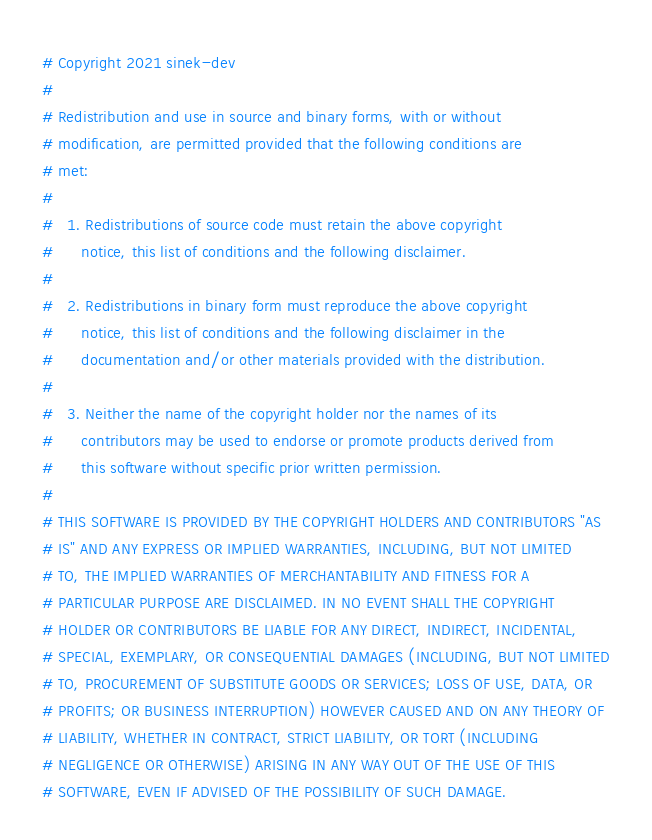Convert code to text. <code><loc_0><loc_0><loc_500><loc_500><_Python_># Copyright 2021 sinek-dev
#
# Redistribution and use in source and binary forms, with or without
# modification, are permitted provided that the following conditions are
# met:
#
#   1. Redistributions of source code must retain the above copyright
#      notice, this list of conditions and the following disclaimer.
#
#   2. Redistributions in binary form must reproduce the above copyright
#      notice, this list of conditions and the following disclaimer in the
#      documentation and/or other materials provided with the distribution.
#
#   3. Neither the name of the copyright holder nor the names of its
#      contributors may be used to endorse or promote products derived from
#      this software without specific prior written permission.
#
# THIS SOFTWARE IS PROVIDED BY THE COPYRIGHT HOLDERS AND CONTRIBUTORS "AS
# IS" AND ANY EXPRESS OR IMPLIED WARRANTIES, INCLUDING, BUT NOT LIMITED
# TO, THE IMPLIED WARRANTIES OF MERCHANTABILITY AND FITNESS FOR A
# PARTICULAR PURPOSE ARE DISCLAIMED. IN NO EVENT SHALL THE COPYRIGHT
# HOLDER OR CONTRIBUTORS BE LIABLE FOR ANY DIRECT, INDIRECT, INCIDENTAL,
# SPECIAL, EXEMPLARY, OR CONSEQUENTIAL DAMAGES (INCLUDING, BUT NOT LIMITED
# TO, PROCUREMENT OF SUBSTITUTE GOODS OR SERVICES; LOSS OF USE, DATA, OR
# PROFITS; OR BUSINESS INTERRUPTION) HOWEVER CAUSED AND ON ANY THEORY OF
# LIABILITY, WHETHER IN CONTRACT, STRICT LIABILITY, OR TORT (INCLUDING
# NEGLIGENCE OR OTHERWISE) ARISING IN ANY WAY OUT OF THE USE OF THIS
# SOFTWARE, EVEN IF ADVISED OF THE POSSIBILITY OF SUCH DAMAGE.
</code> 